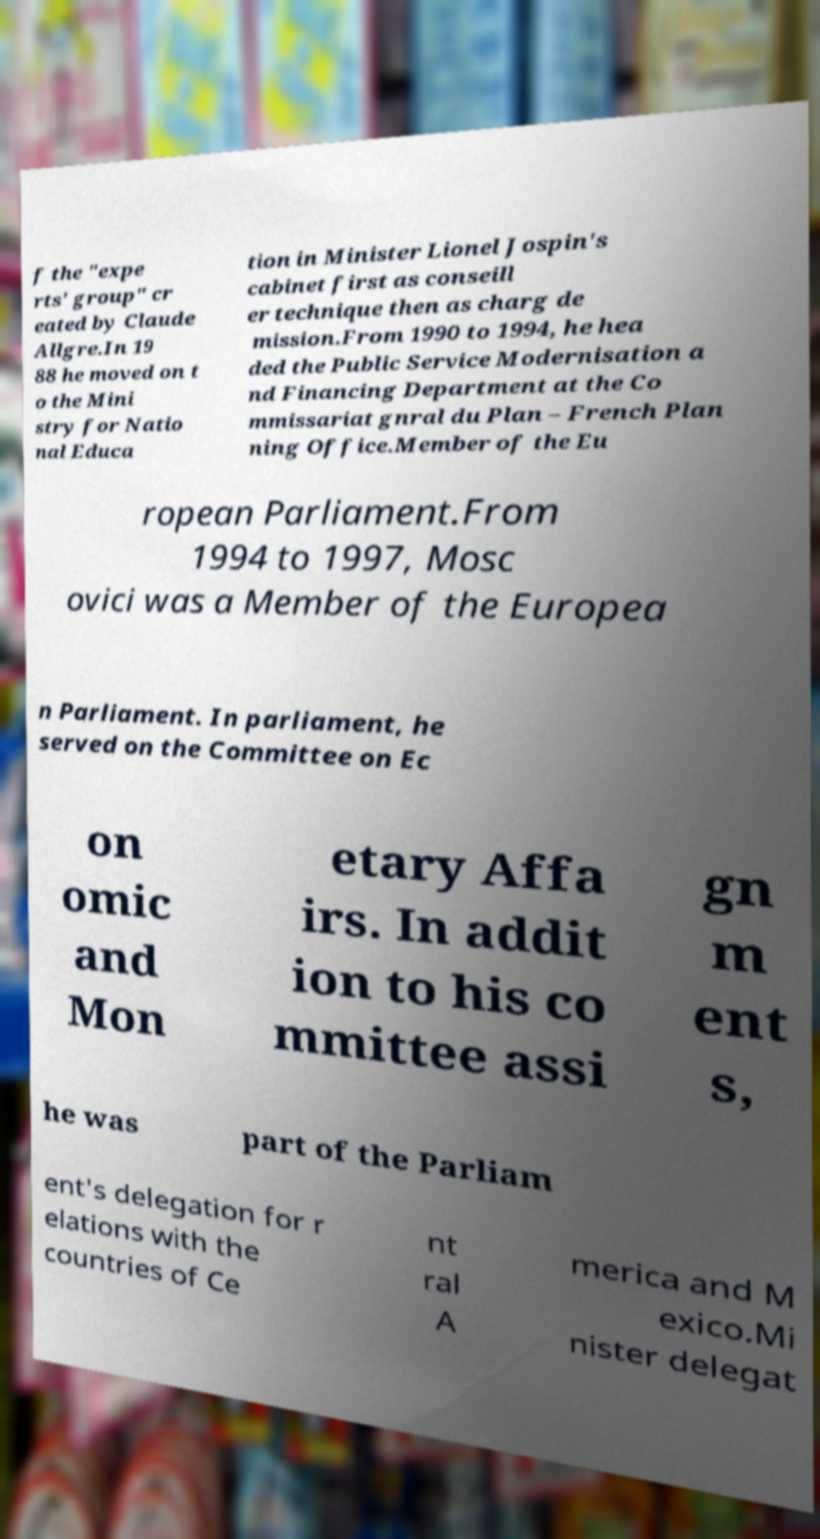Could you extract and type out the text from this image? f the "expe rts' group" cr eated by Claude Allgre.In 19 88 he moved on t o the Mini stry for Natio nal Educa tion in Minister Lionel Jospin's cabinet first as conseill er technique then as charg de mission.From 1990 to 1994, he hea ded the Public Service Modernisation a nd Financing Department at the Co mmissariat gnral du Plan – French Plan ning Office.Member of the Eu ropean Parliament.From 1994 to 1997, Mosc ovici was a Member of the Europea n Parliament. In parliament, he served on the Committee on Ec on omic and Mon etary Affa irs. In addit ion to his co mmittee assi gn m ent s, he was part of the Parliam ent's delegation for r elations with the countries of Ce nt ral A merica and M exico.Mi nister delegat 